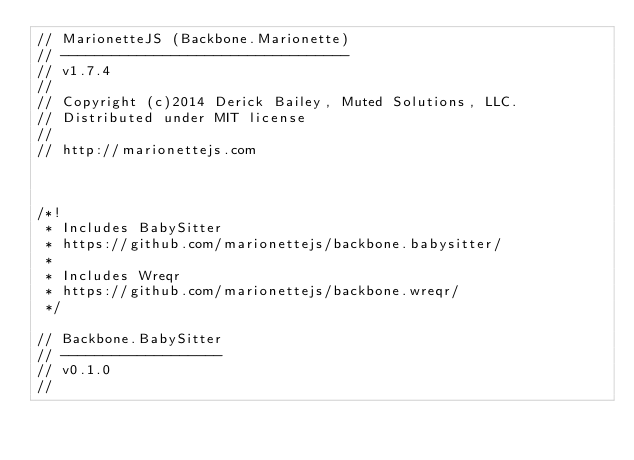<code> <loc_0><loc_0><loc_500><loc_500><_JavaScript_>// MarionetteJS (Backbone.Marionette)
// ----------------------------------
// v1.7.4
//
// Copyright (c)2014 Derick Bailey, Muted Solutions, LLC.
// Distributed under MIT license
//
// http://marionettejs.com



/*!
 * Includes BabySitter
 * https://github.com/marionettejs/backbone.babysitter/
 *
 * Includes Wreqr
 * https://github.com/marionettejs/backbone.wreqr/
 */

// Backbone.BabySitter
// -------------------
// v0.1.0
//</code> 